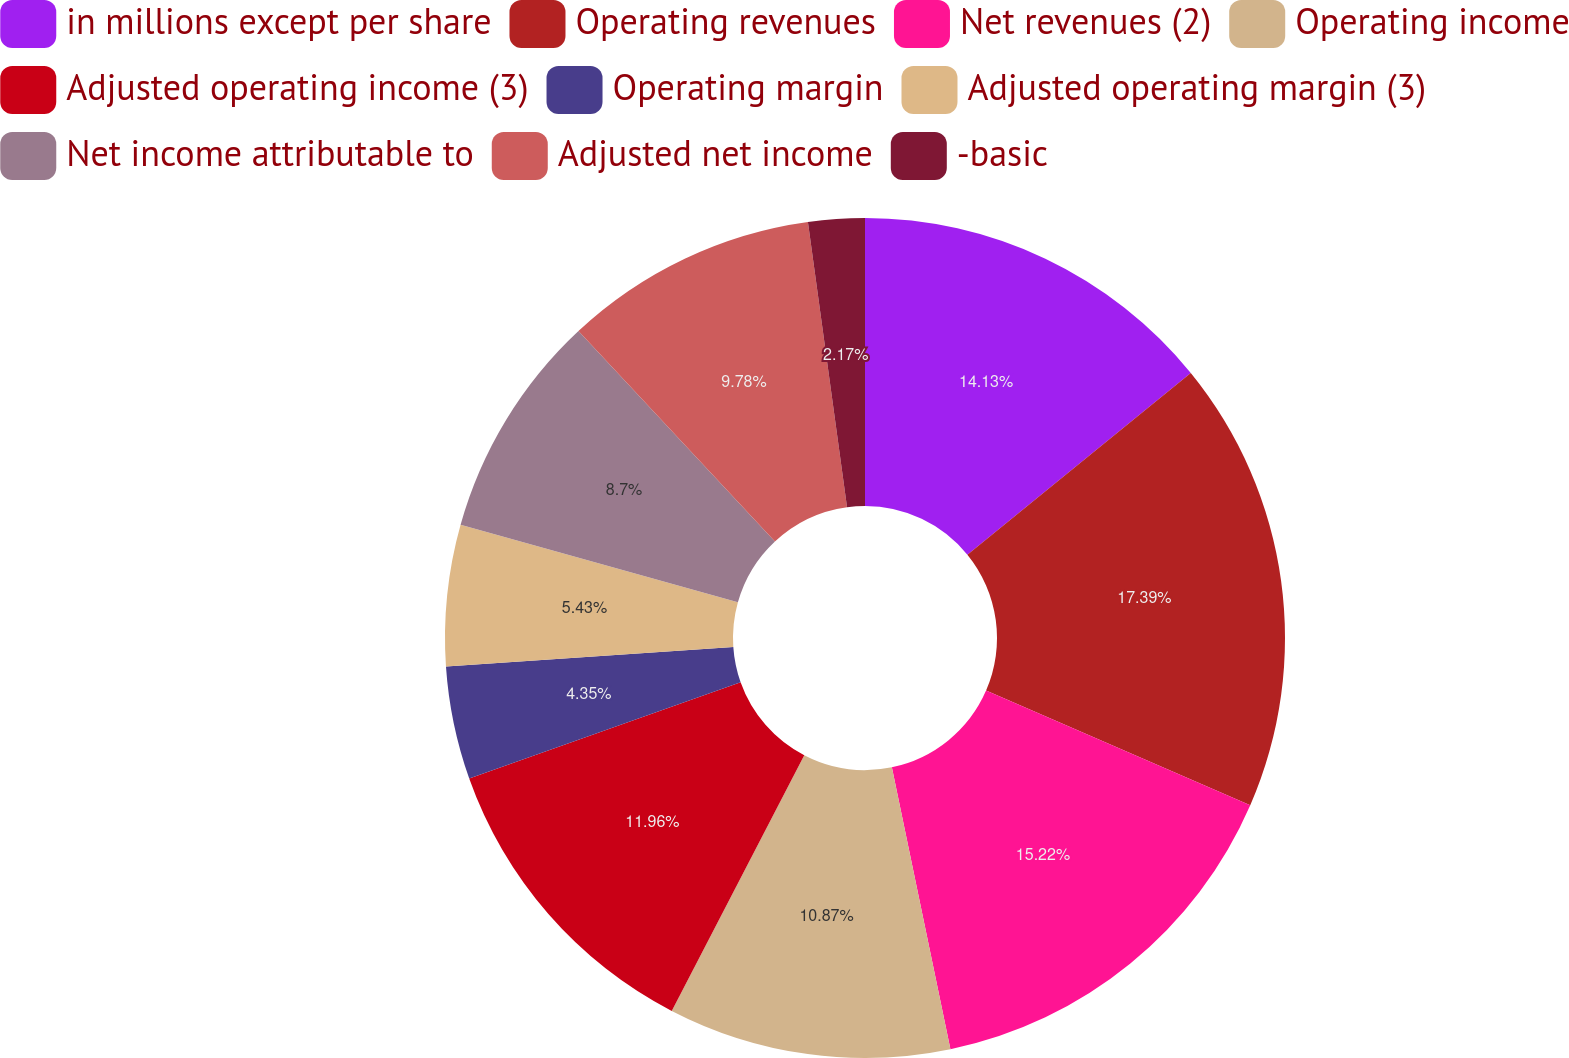<chart> <loc_0><loc_0><loc_500><loc_500><pie_chart><fcel>in millions except per share<fcel>Operating revenues<fcel>Net revenues (2)<fcel>Operating income<fcel>Adjusted operating income (3)<fcel>Operating margin<fcel>Adjusted operating margin (3)<fcel>Net income attributable to<fcel>Adjusted net income<fcel>-basic<nl><fcel>14.13%<fcel>17.39%<fcel>15.22%<fcel>10.87%<fcel>11.96%<fcel>4.35%<fcel>5.43%<fcel>8.7%<fcel>9.78%<fcel>2.17%<nl></chart> 